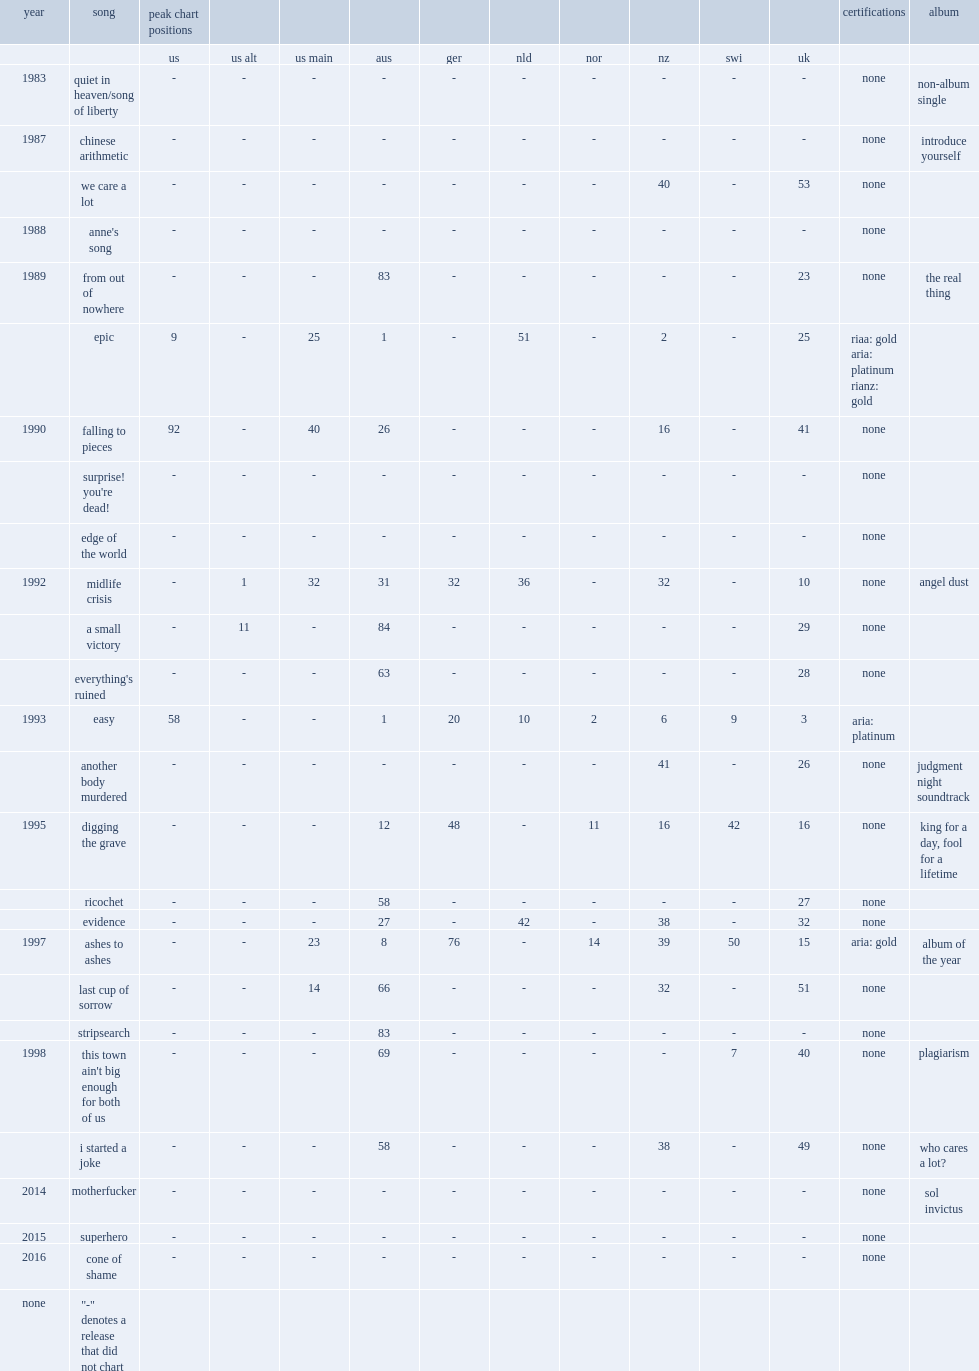When did the single"midlife crisis" release? 1992.0. 